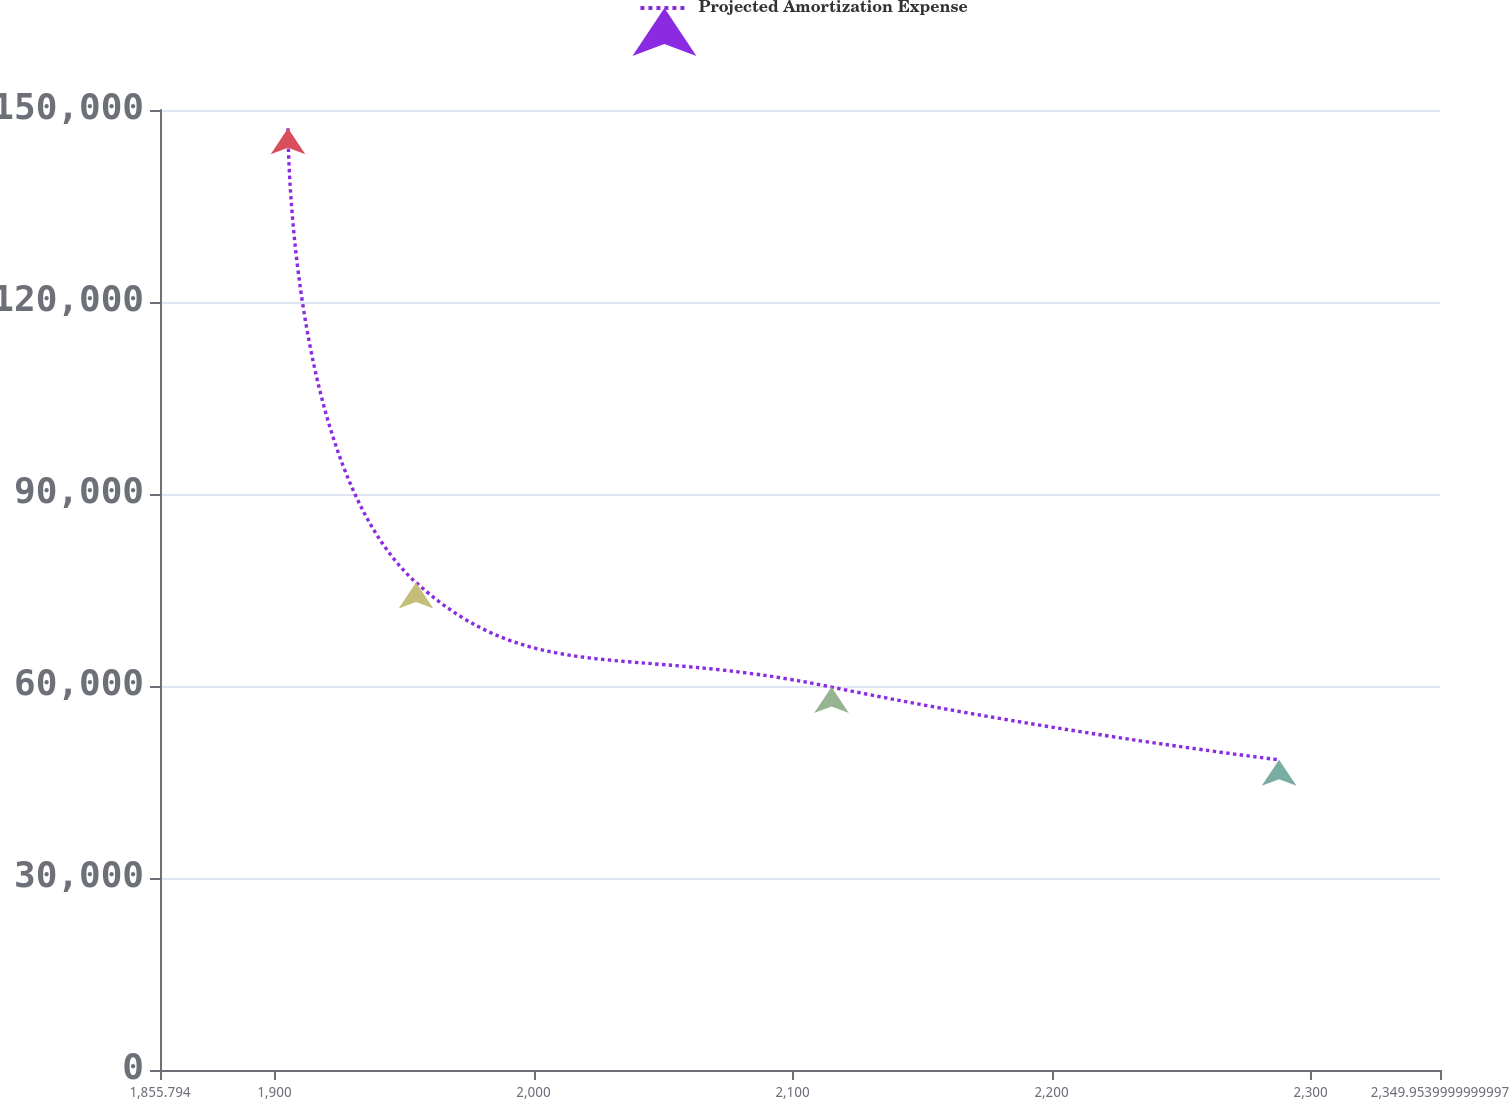<chart> <loc_0><loc_0><loc_500><loc_500><line_chart><ecel><fcel>Projected Amortization Expense<nl><fcel>1905.21<fcel>147150<nl><fcel>1954.63<fcel>76171.6<nl><fcel>2115.04<fcel>59833.5<nl><fcel>2287.84<fcel>48463.8<nl><fcel>2399.37<fcel>33453.6<nl></chart> 